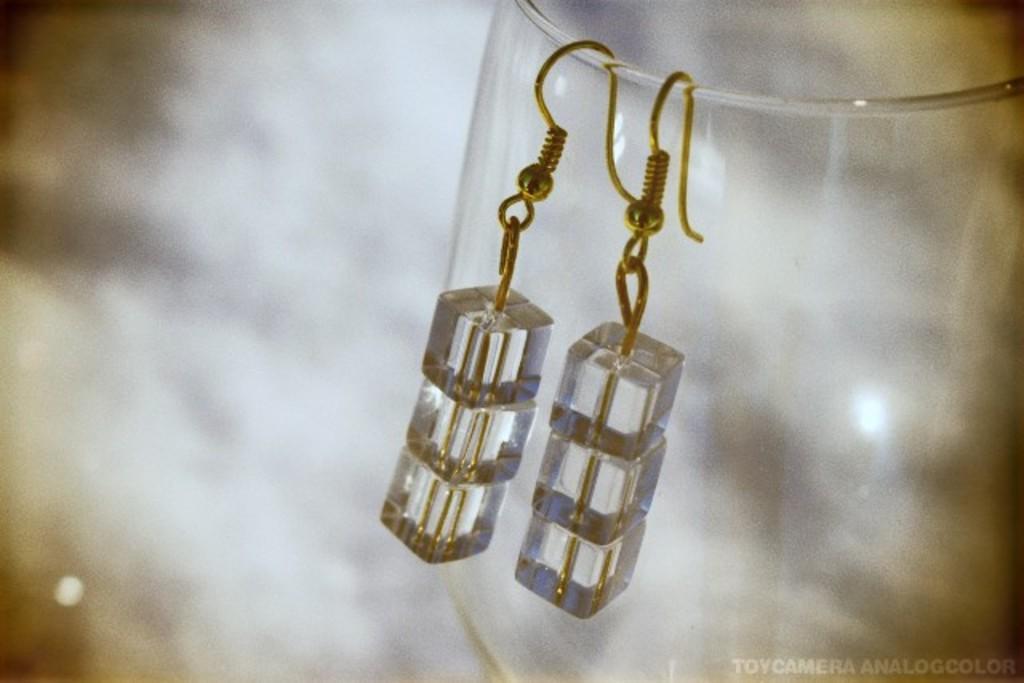Can you describe this image briefly? In this image we can see a glass. On the glass there are earrings hanged. In the background it is blur. In the right bottom corner something is written. 